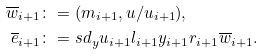Convert formula to latex. <formula><loc_0><loc_0><loc_500><loc_500>\overline { w } _ { i + 1 } & \colon = ( m _ { i + 1 } , u / u _ { i + 1 } ) , \\ \overline { e } _ { i + 1 } & \colon = s d _ { y } u _ { i + 1 } l _ { i + 1 } y _ { i + 1 } r _ { i + 1 } \overline { w } _ { i + 1 } .</formula> 